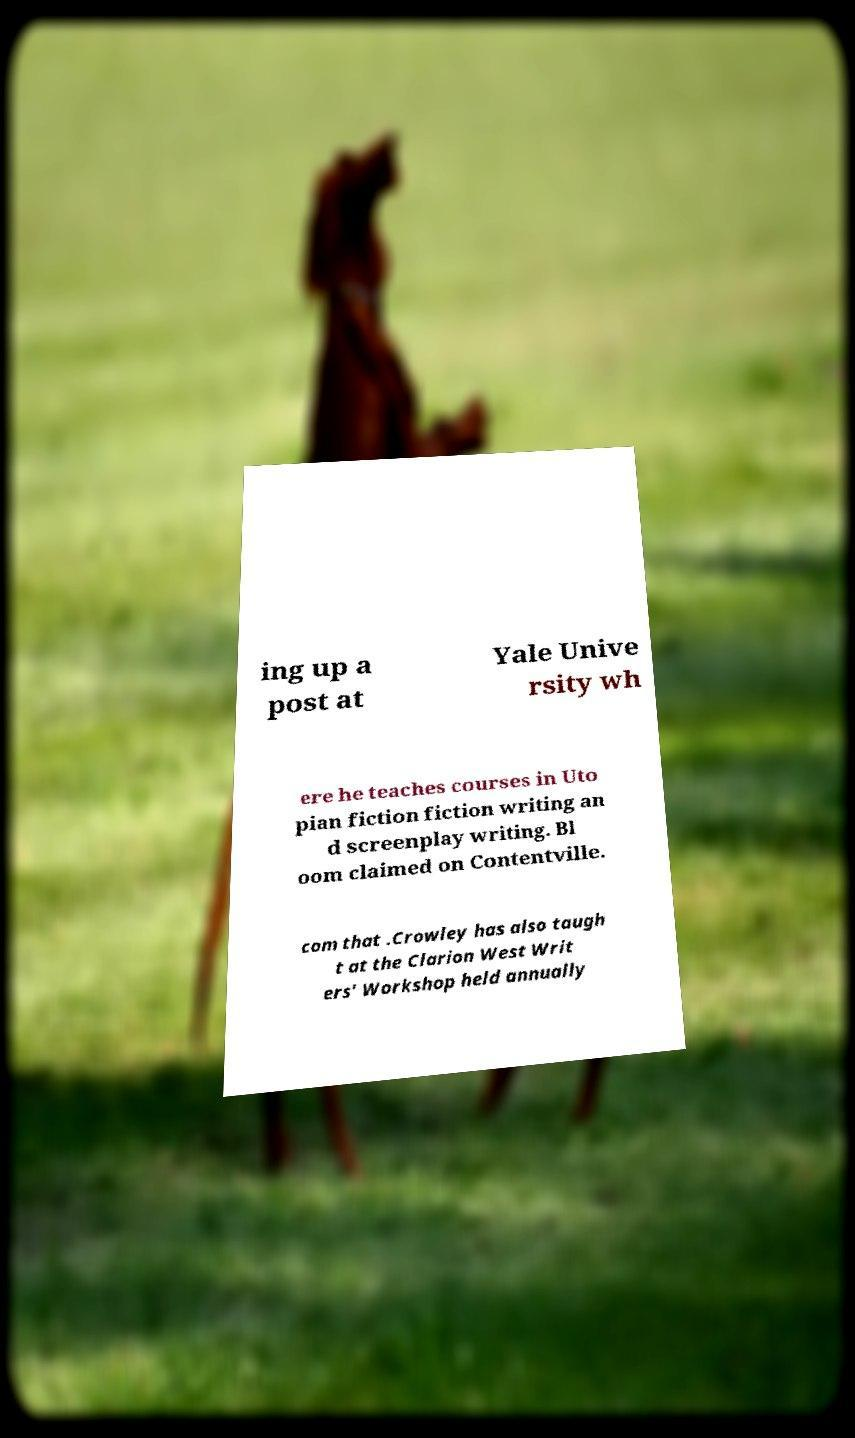Can you read and provide the text displayed in the image?This photo seems to have some interesting text. Can you extract and type it out for me? ing up a post at Yale Unive rsity wh ere he teaches courses in Uto pian fiction fiction writing an d screenplay writing. Bl oom claimed on Contentville. com that .Crowley has also taugh t at the Clarion West Writ ers' Workshop held annually 